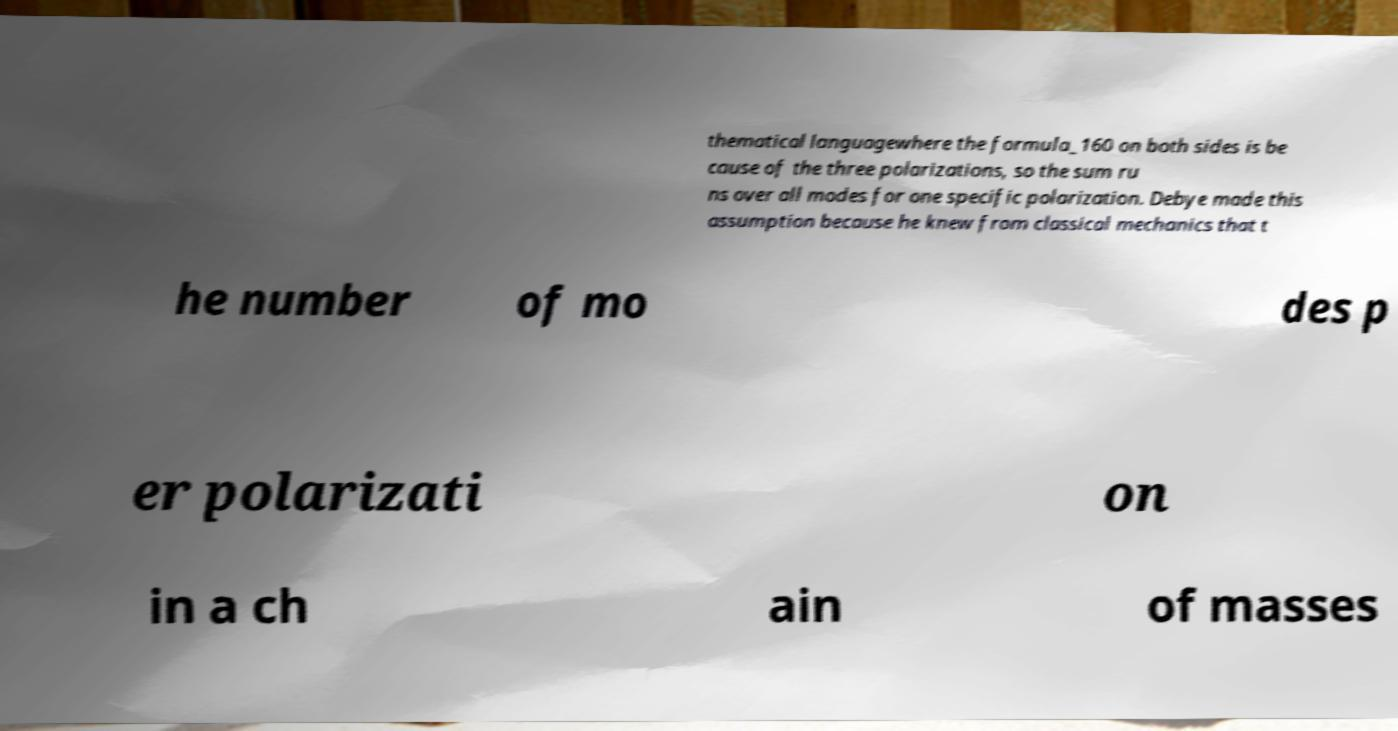Can you accurately transcribe the text from the provided image for me? thematical languagewhere the formula_160 on both sides is be cause of the three polarizations, so the sum ru ns over all modes for one specific polarization. Debye made this assumption because he knew from classical mechanics that t he number of mo des p er polarizati on in a ch ain of masses 